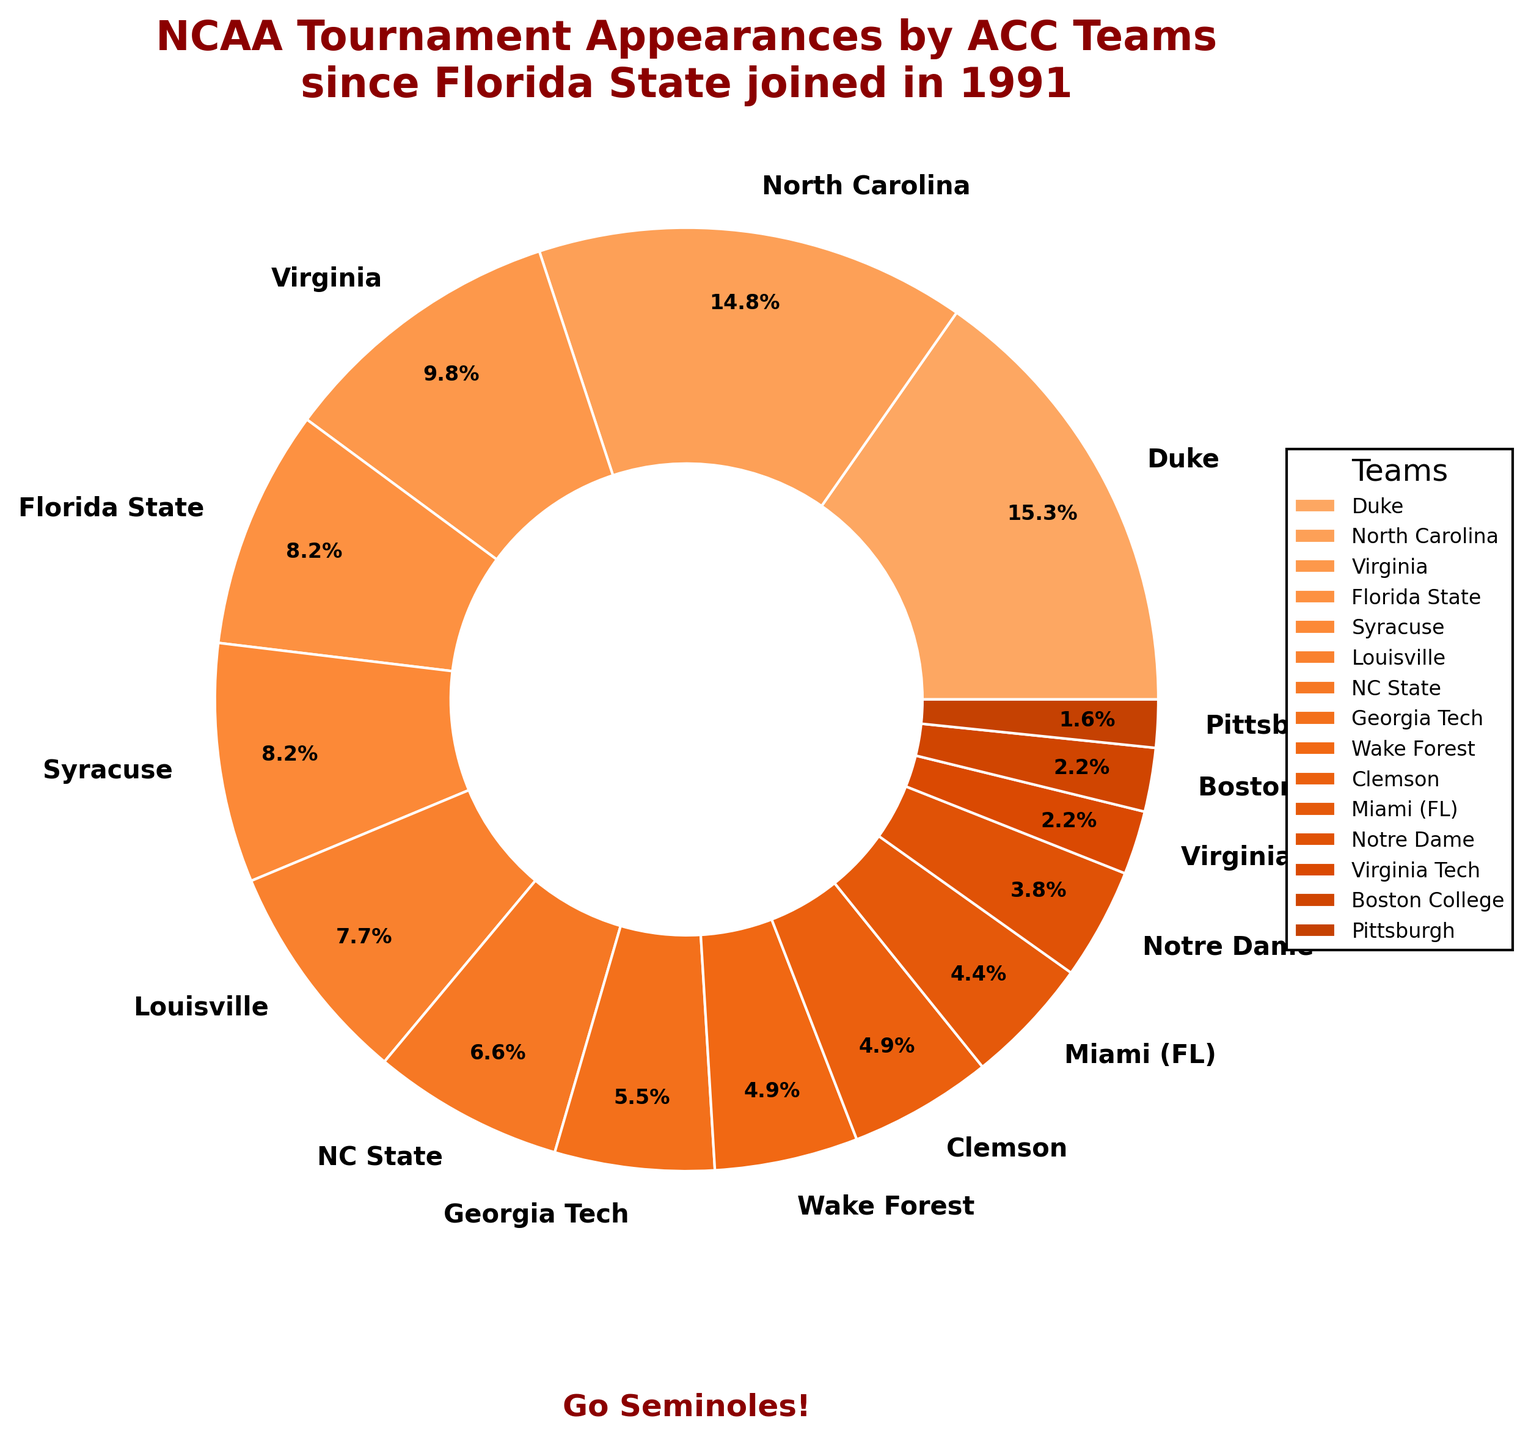Which team has the highest percentage of NCAA Tournament appearances? The largest wedge in the pie chart represents the team with the highest percentage. The team shown with the largest wedge is Duke.
Answer: Duke Which two teams have the same number of appearances? Inspect the wedges to identify teams with the same percentage. Florida State and Syracuse both have wedges labeled with the same percentage value, which is 15 appearances each.
Answer: Florida State and Syracuse How many more tournament appearances does North Carolina have compared to Virginia? North Carolina has 27 appearances, and Virginia has 18 appearances. Subtracting gives 27 - 18 = 9.
Answer: 9 Which teams have blue-colored wedges? By inspecting the colors of the pie chart wedges, no teams are displayed with a blue-colored wedge in the chart, as all teams have orange-shaded wedges.
Answer: None What is the combined percentage of appearances for Georgia Tech and Clemson? Georgia Tech has 10 appearances and Clemson has 9 appearances. Adding their percentages and dividing by the total sum, 10/164 and 9/164, then multiplying by 100: (10 + 9) / 164 * 100 = 11.5%.
Answer: 11.5% Which team falls just below North Carolina in terms of NCAA Tournament appearances? Observing the sorted listing, North Carolina is second with 27 appearances, and the next highest is Virginia with 18.
Answer: Virginia How many teams have made fewer than 5 appearances? From the visual, Boston College, Virginia Tech, and Pittsburgh each have appearances fewer than 5. Counting the teams results in 3.
Answer: 3 Which group's wedge is larger in the chart: Wake Forest or Notre Dame? Comparing the wedges visually or checking their portion sizes, Wake Forest's wedge (9 appearances) is larger than Notre Dame's wedge (7 appearances).
Answer: Wake Forest 